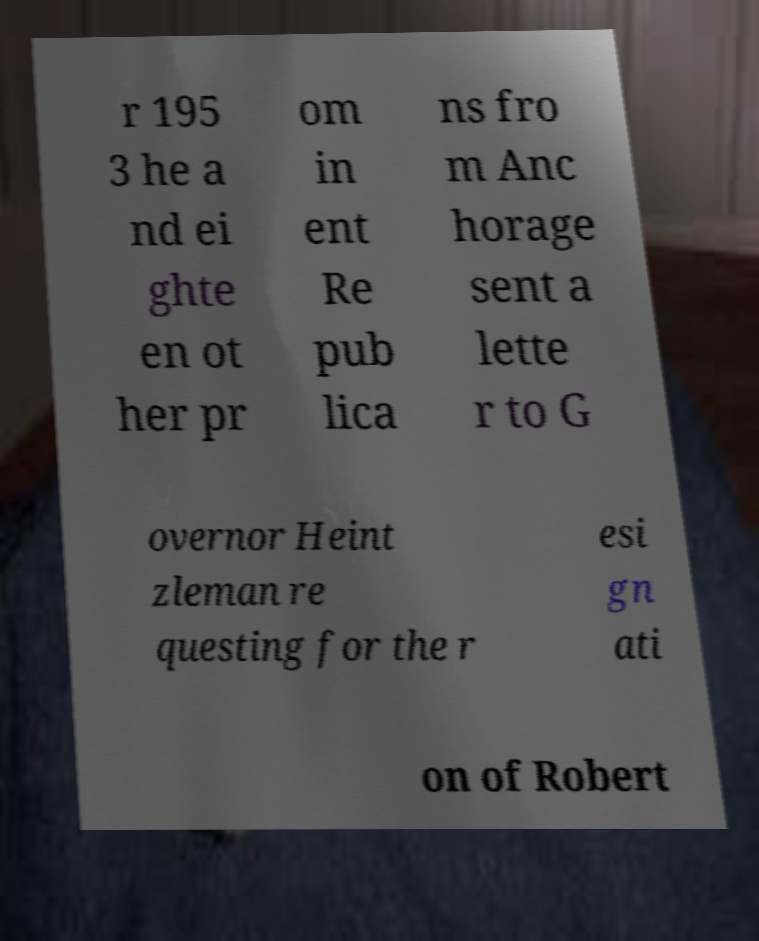Please identify and transcribe the text found in this image. r 195 3 he a nd ei ghte en ot her pr om in ent Re pub lica ns fro m Anc horage sent a lette r to G overnor Heint zleman re questing for the r esi gn ati on of Robert 